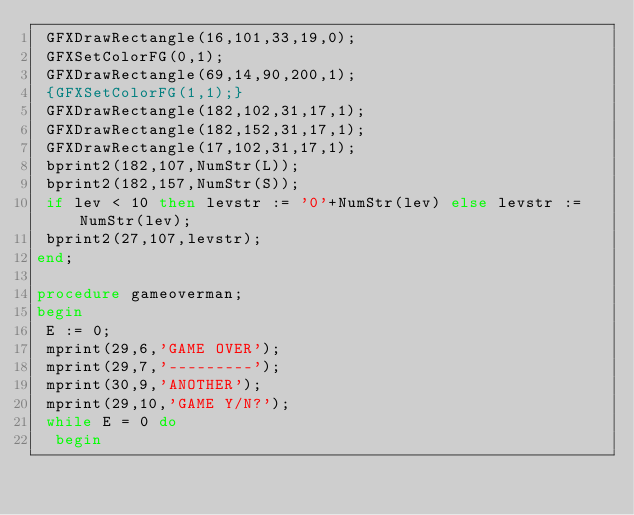Convert code to text. <code><loc_0><loc_0><loc_500><loc_500><_Pascal_> GFXDrawRectangle(16,101,33,19,0);
 GFXSetColorFG(0,1);
 GFXDrawRectangle(69,14,90,200,1);
 {GFXSetColorFG(1,1);}
 GFXDrawRectangle(182,102,31,17,1);
 GFXDrawRectangle(182,152,31,17,1);
 GFXDrawRectangle(17,102,31,17,1);
 bprint2(182,107,NumStr(L));
 bprint2(182,157,NumStr(S));
 if lev < 10 then levstr := '0'+NumStr(lev) else levstr := NumStr(lev);
 bprint2(27,107,levstr);
end;

procedure gameoverman;
begin
 E := 0;
 mprint(29,6,'GAME OVER');
 mprint(29,7,'---------');
 mprint(30,9,'ANOTHER');
 mprint(29,10,'GAME Y/N?');
 while E = 0 do
  begin</code> 